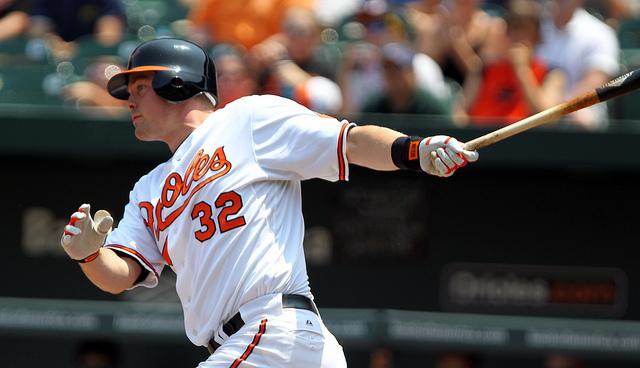Did the man hit the ball?
Write a very short answer. Yes. Are the spectators clapping?
Be succinct. Yes. What number is the jersey?
Be succinct. 32. 